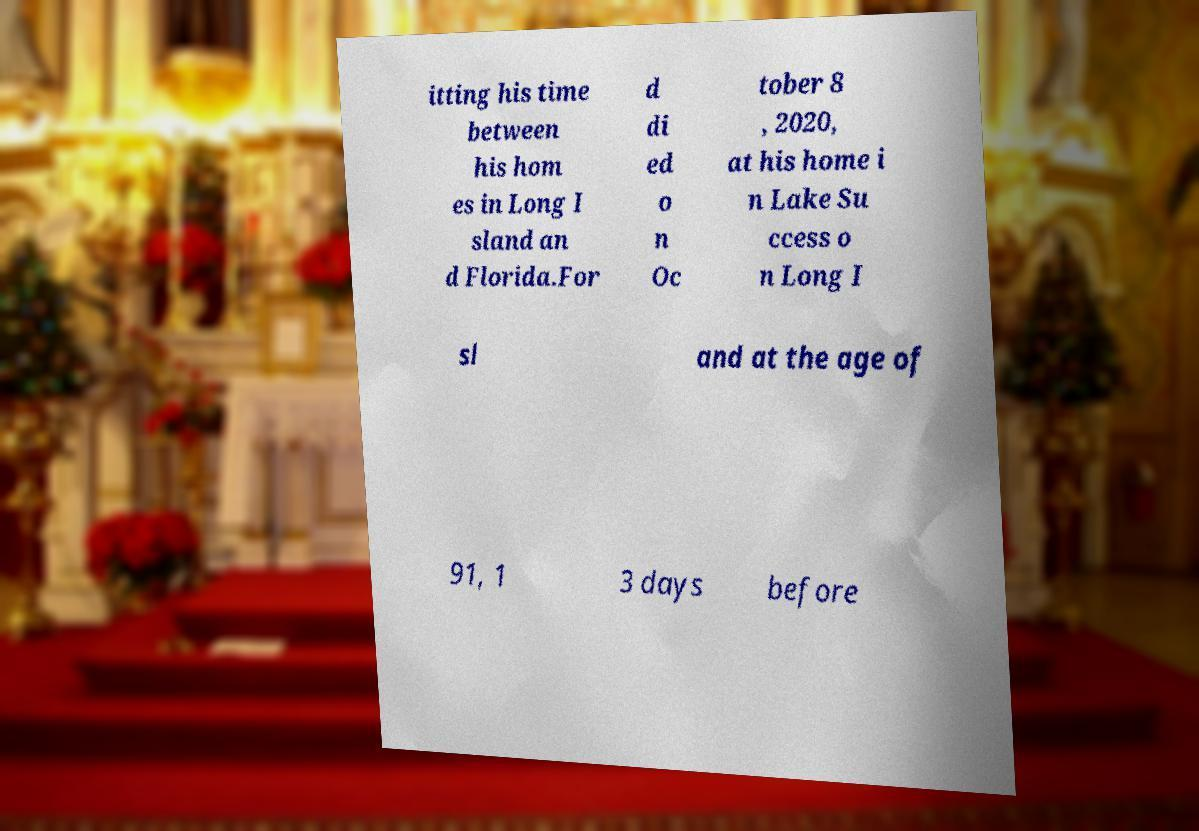Please identify and transcribe the text found in this image. itting his time between his hom es in Long I sland an d Florida.For d di ed o n Oc tober 8 , 2020, at his home i n Lake Su ccess o n Long I sl and at the age of 91, 1 3 days before 